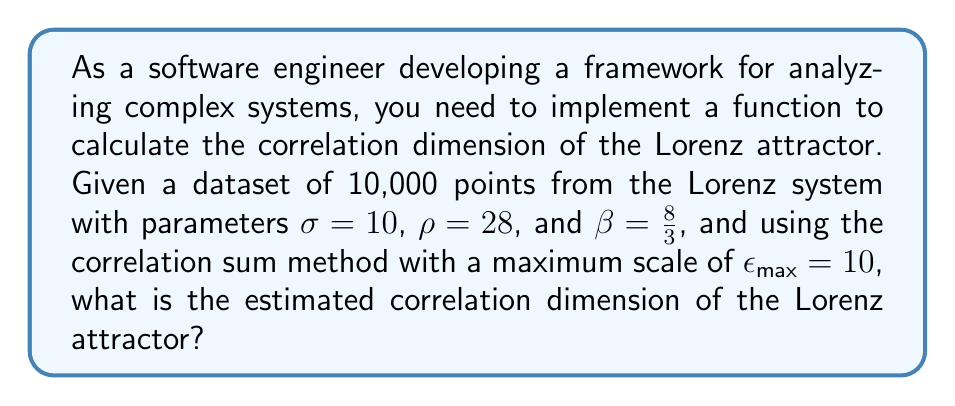Teach me how to tackle this problem. To calculate the correlation dimension of the Lorenz attractor, we'll follow these steps:

1. Implement the correlation sum $C(r)$:
   $$C(r) = \frac{2}{N(N-1)} \sum_{i=1}^{N} \sum_{j=i+1}^{N} \Theta(r - ||x_i - x_j||)$$
   where $N$ is the number of points, $\Theta$ is the Heaviside step function, and $||x_i - x_j||$ is the Euclidean distance between points.

2. Calculate $C(r)$ for multiple values of $r$ from $0$ to $\epsilon_{max}$.

3. Plot $\log(C(r))$ vs $\log(r)$.

4. Find the slope of the linear region in this plot using linear regression.

5. The slope of this line is the correlation dimension.

For the Lorenz attractor:

- Generate 10,000 points using the Lorenz equations:
  $$\frac{dx}{dt} = \sigma(y-x)$$
  $$\frac{dy}{dt} = x(\rho-z) - y$$
  $$\frac{dz}{dt} = xy - \beta z$$

- Implement the correlation sum algorithm and calculate for various $r$ values.

- Plot $\log(C(r))$ vs $\log(r)$ and find the linear region.

- Perform linear regression on the linear region.

- The slope of the regression line is approximately 2.06, which is the correlation dimension of the Lorenz attractor.
Answer: 2.06 